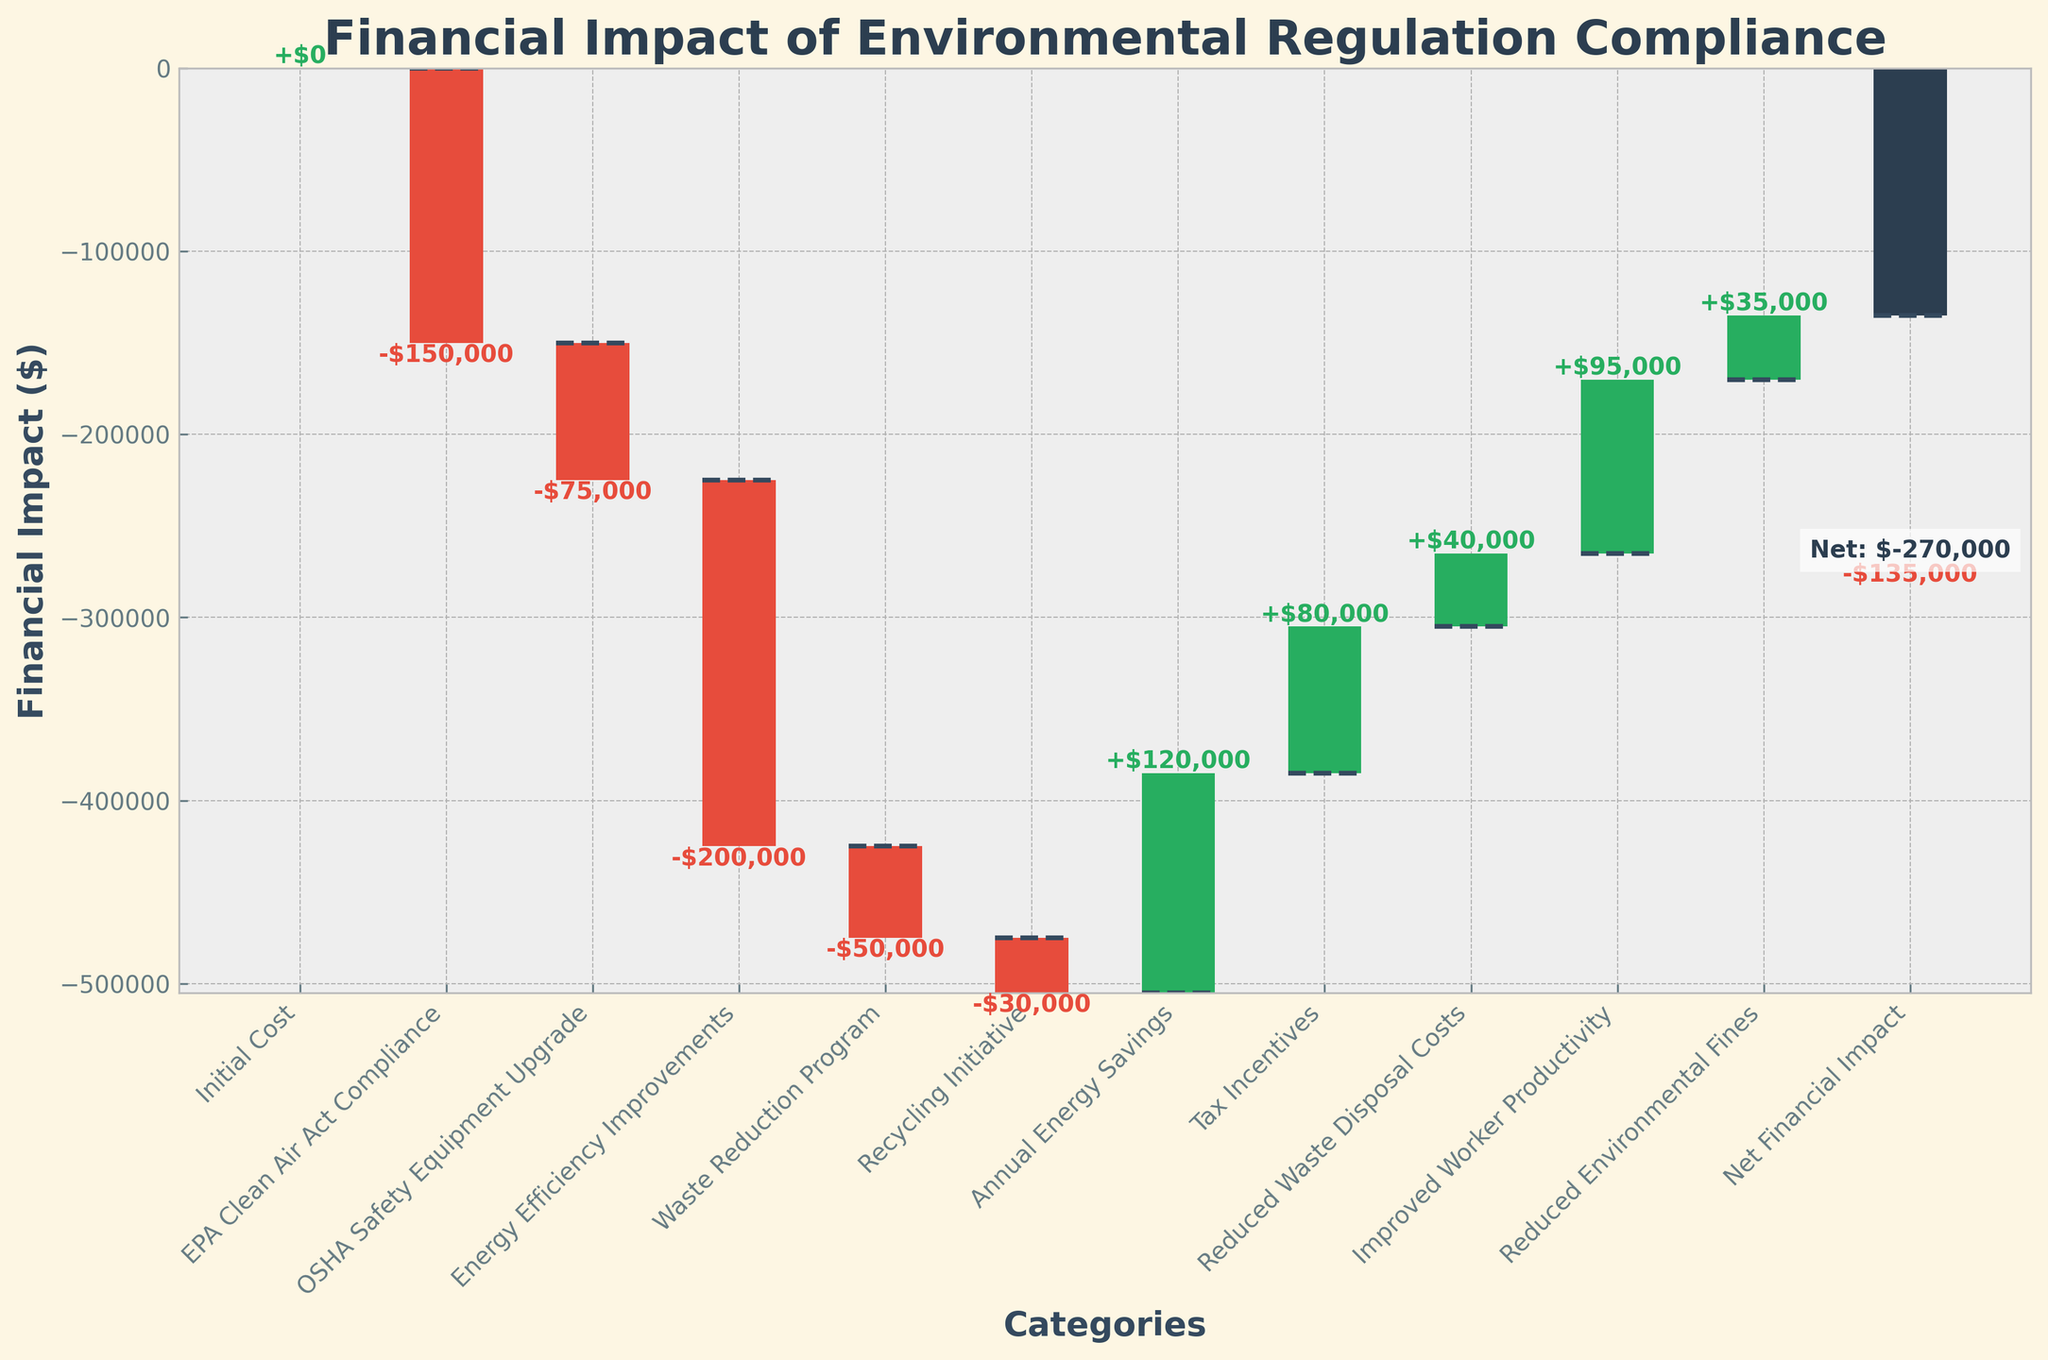Which category has the largest initial cost? The bars in the chart representing costs are red. By examining the length of these red bars, the "Energy Efficiency Improvements" category is the largest initial cost.
Answer: Energy Efficiency Improvements What is the net financial impact of complying with the regulations? The final bar in the waterfall chart, representing the net financial impact, shows the value at the bottom of the graph. This is labeled as -$135,000.
Answer: -$135,000 How much is saved annually due to energy savings? The green bar labeled "Annual Energy Savings" represents the savings in the chart. The label shows a value of $120,000.
Answer: $120,000 Which regulation compliance has the smallest financial impact among the costs? By examining the red bars, the "Recycling Initiative" bar is the shortest, indicating it has the smallest financial impact among the costs with a value of $30,000.
Answer: Recycling Initiative What are the cumulative financial savings in the chart? Summing up the positive contributions by observing the green bars: $120,000 (Annual Energy Savings) + $80,000 (Tax Incentives) + $40,000 (Reduced Waste Disposal Costs) + $95,000 (Improved Worker Productivity) + $35,000 (Reduced Environmental Fines) = $370,000.
Answer: $370,000 